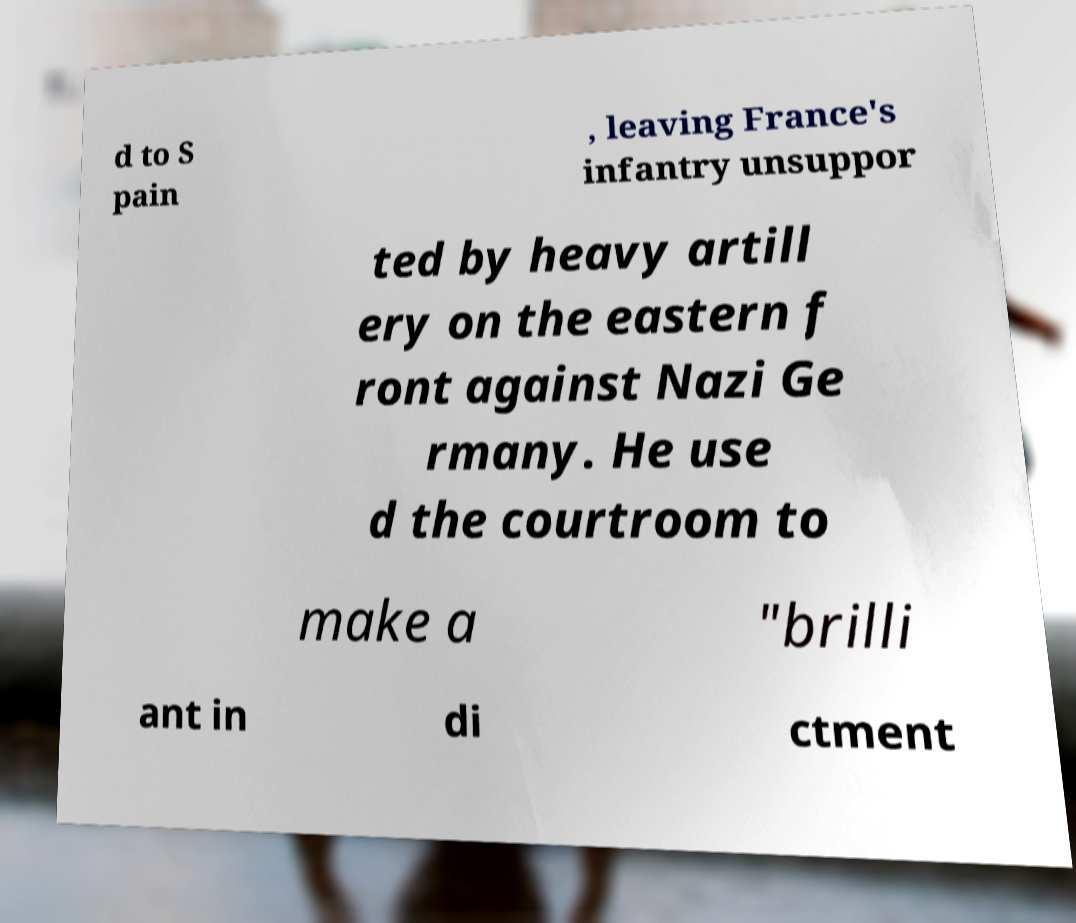Could you assist in decoding the text presented in this image and type it out clearly? d to S pain , leaving France's infantry unsuppor ted by heavy artill ery on the eastern f ront against Nazi Ge rmany. He use d the courtroom to make a "brilli ant in di ctment 